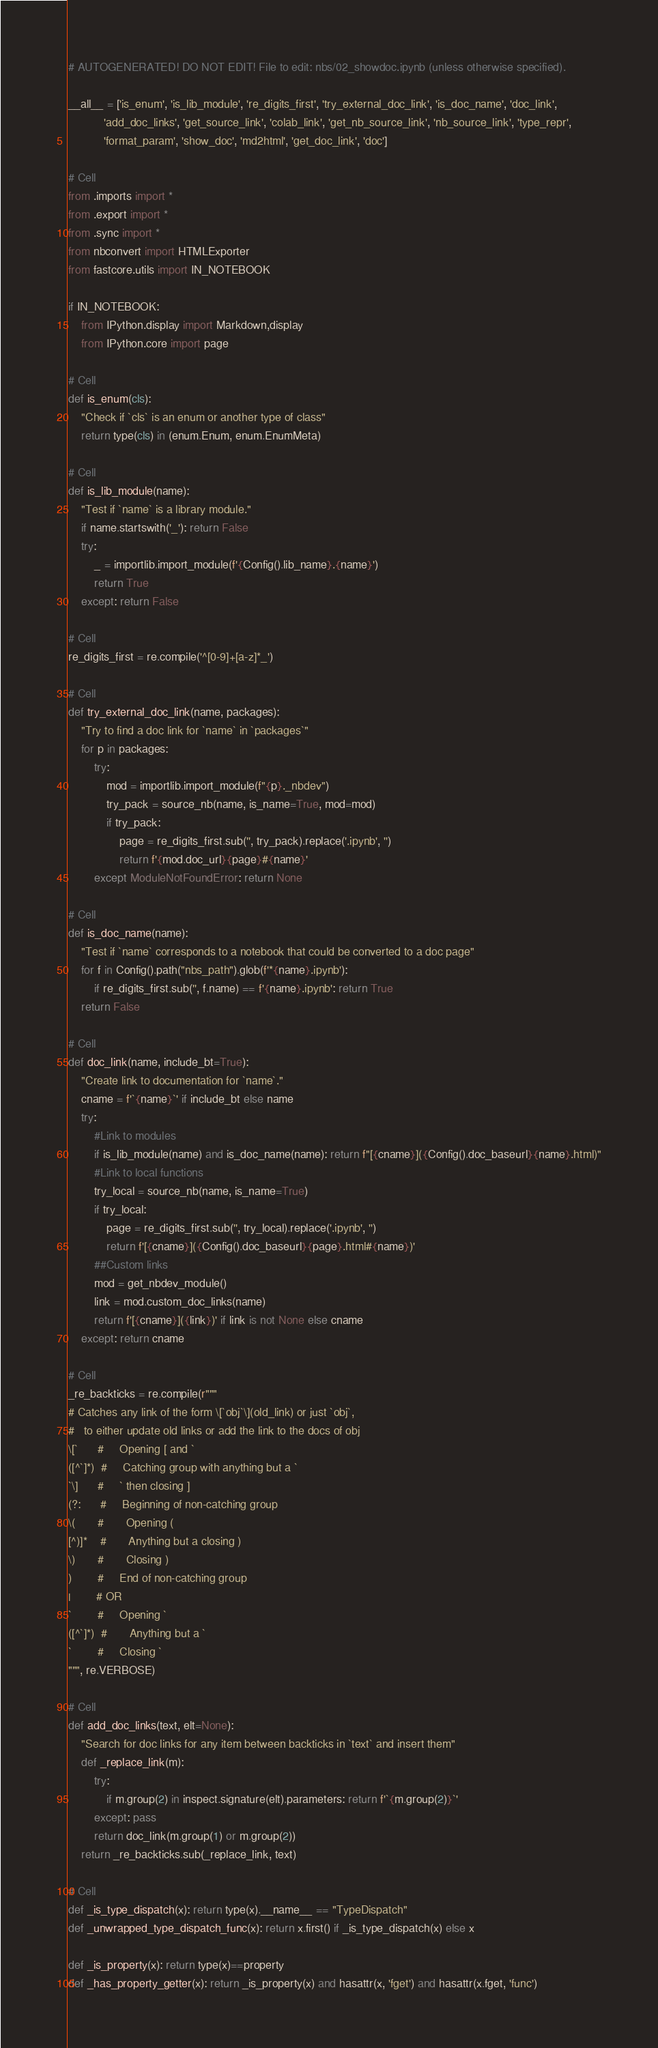<code> <loc_0><loc_0><loc_500><loc_500><_Python_># AUTOGENERATED! DO NOT EDIT! File to edit: nbs/02_showdoc.ipynb (unless otherwise specified).

__all__ = ['is_enum', 'is_lib_module', 're_digits_first', 'try_external_doc_link', 'is_doc_name', 'doc_link',
           'add_doc_links', 'get_source_link', 'colab_link', 'get_nb_source_link', 'nb_source_link', 'type_repr',
           'format_param', 'show_doc', 'md2html', 'get_doc_link', 'doc']

# Cell
from .imports import *
from .export import *
from .sync import *
from nbconvert import HTMLExporter
from fastcore.utils import IN_NOTEBOOK

if IN_NOTEBOOK:
    from IPython.display import Markdown,display
    from IPython.core import page

# Cell
def is_enum(cls):
    "Check if `cls` is an enum or another type of class"
    return type(cls) in (enum.Enum, enum.EnumMeta)

# Cell
def is_lib_module(name):
    "Test if `name` is a library module."
    if name.startswith('_'): return False
    try:
        _ = importlib.import_module(f'{Config().lib_name}.{name}')
        return True
    except: return False

# Cell
re_digits_first = re.compile('^[0-9]+[a-z]*_')

# Cell
def try_external_doc_link(name, packages):
    "Try to find a doc link for `name` in `packages`"
    for p in packages:
        try:
            mod = importlib.import_module(f"{p}._nbdev")
            try_pack = source_nb(name, is_name=True, mod=mod)
            if try_pack:
                page = re_digits_first.sub('', try_pack).replace('.ipynb', '')
                return f'{mod.doc_url}{page}#{name}'
        except ModuleNotFoundError: return None

# Cell
def is_doc_name(name):
    "Test if `name` corresponds to a notebook that could be converted to a doc page"
    for f in Config().path("nbs_path").glob(f'*{name}.ipynb'):
        if re_digits_first.sub('', f.name) == f'{name}.ipynb': return True
    return False

# Cell
def doc_link(name, include_bt=True):
    "Create link to documentation for `name`."
    cname = f'`{name}`' if include_bt else name
    try:
        #Link to modules
        if is_lib_module(name) and is_doc_name(name): return f"[{cname}]({Config().doc_baseurl}{name}.html)"
        #Link to local functions
        try_local = source_nb(name, is_name=True)
        if try_local:
            page = re_digits_first.sub('', try_local).replace('.ipynb', '')
            return f'[{cname}]({Config().doc_baseurl}{page}.html#{name})'
        ##Custom links
        mod = get_nbdev_module()
        link = mod.custom_doc_links(name)
        return f'[{cname}]({link})' if link is not None else cname
    except: return cname

# Cell
_re_backticks = re.compile(r"""
# Catches any link of the form \[`obj`\](old_link) or just `obj`,
#   to either update old links or add the link to the docs of obj
\[`      #     Opening [ and `
([^`]*)  #     Catching group with anything but a `
`\]      #     ` then closing ]
(?:      #     Beginning of non-catching group
\(       #       Opening (
[^)]*    #       Anything but a closing )
\)       #       Closing )
)        #     End of non-catching group
|        # OR
`        #     Opening `
([^`]*)  #       Anything but a `
`        #     Closing `
""", re.VERBOSE)

# Cell
def add_doc_links(text, elt=None):
    "Search for doc links for any item between backticks in `text` and insert them"
    def _replace_link(m):
        try:
            if m.group(2) in inspect.signature(elt).parameters: return f'`{m.group(2)}`'
        except: pass
        return doc_link(m.group(1) or m.group(2))
    return _re_backticks.sub(_replace_link, text)

# Cell
def _is_type_dispatch(x): return type(x).__name__ == "TypeDispatch"
def _unwrapped_type_dispatch_func(x): return x.first() if _is_type_dispatch(x) else x

def _is_property(x): return type(x)==property
def _has_property_getter(x): return _is_property(x) and hasattr(x, 'fget') and hasattr(x.fget, 'func')</code> 